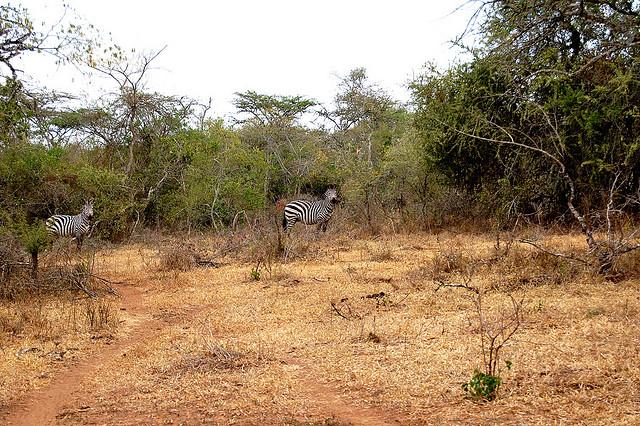Is there only one species in this picture?
Be succinct. Yes. Are there any trees present in this picture?
Give a very brief answer. Yes. How many legs do the striped animals have all together?
Keep it brief. 8. What type of animals are seen?
Be succinct. Zebra. 